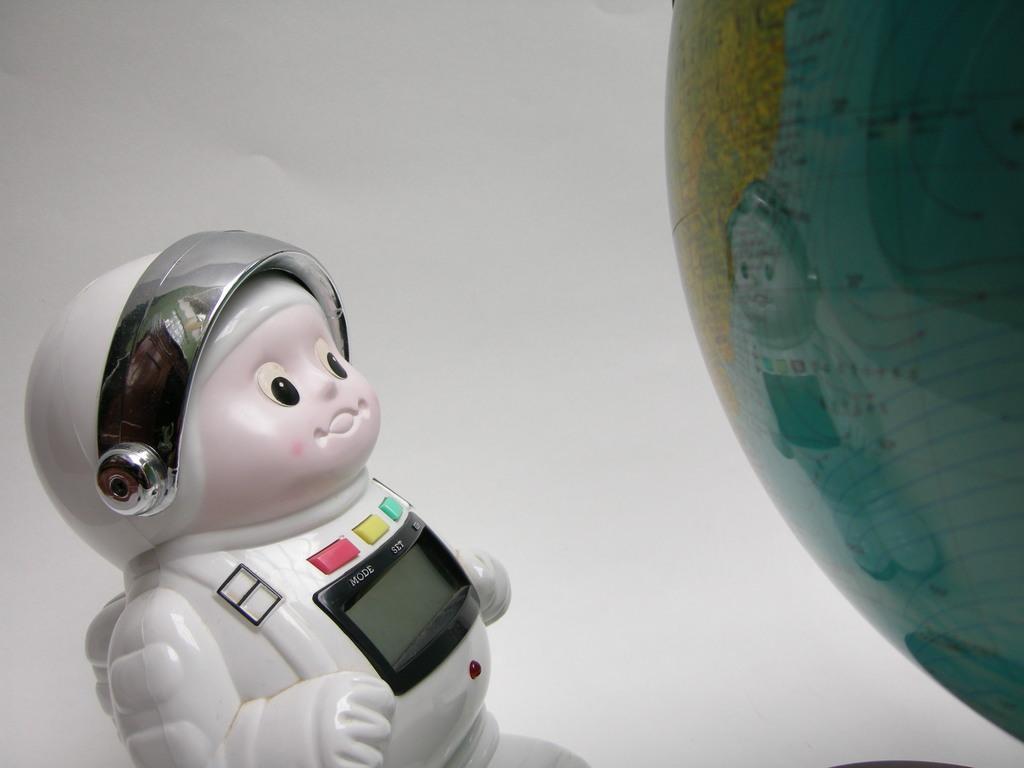Could you give a brief overview of what you see in this image? On the bottom right there is a astronaut toy. Here we can see screen and buttons. On the right there is a globe ball. Here we can see white color wall. 